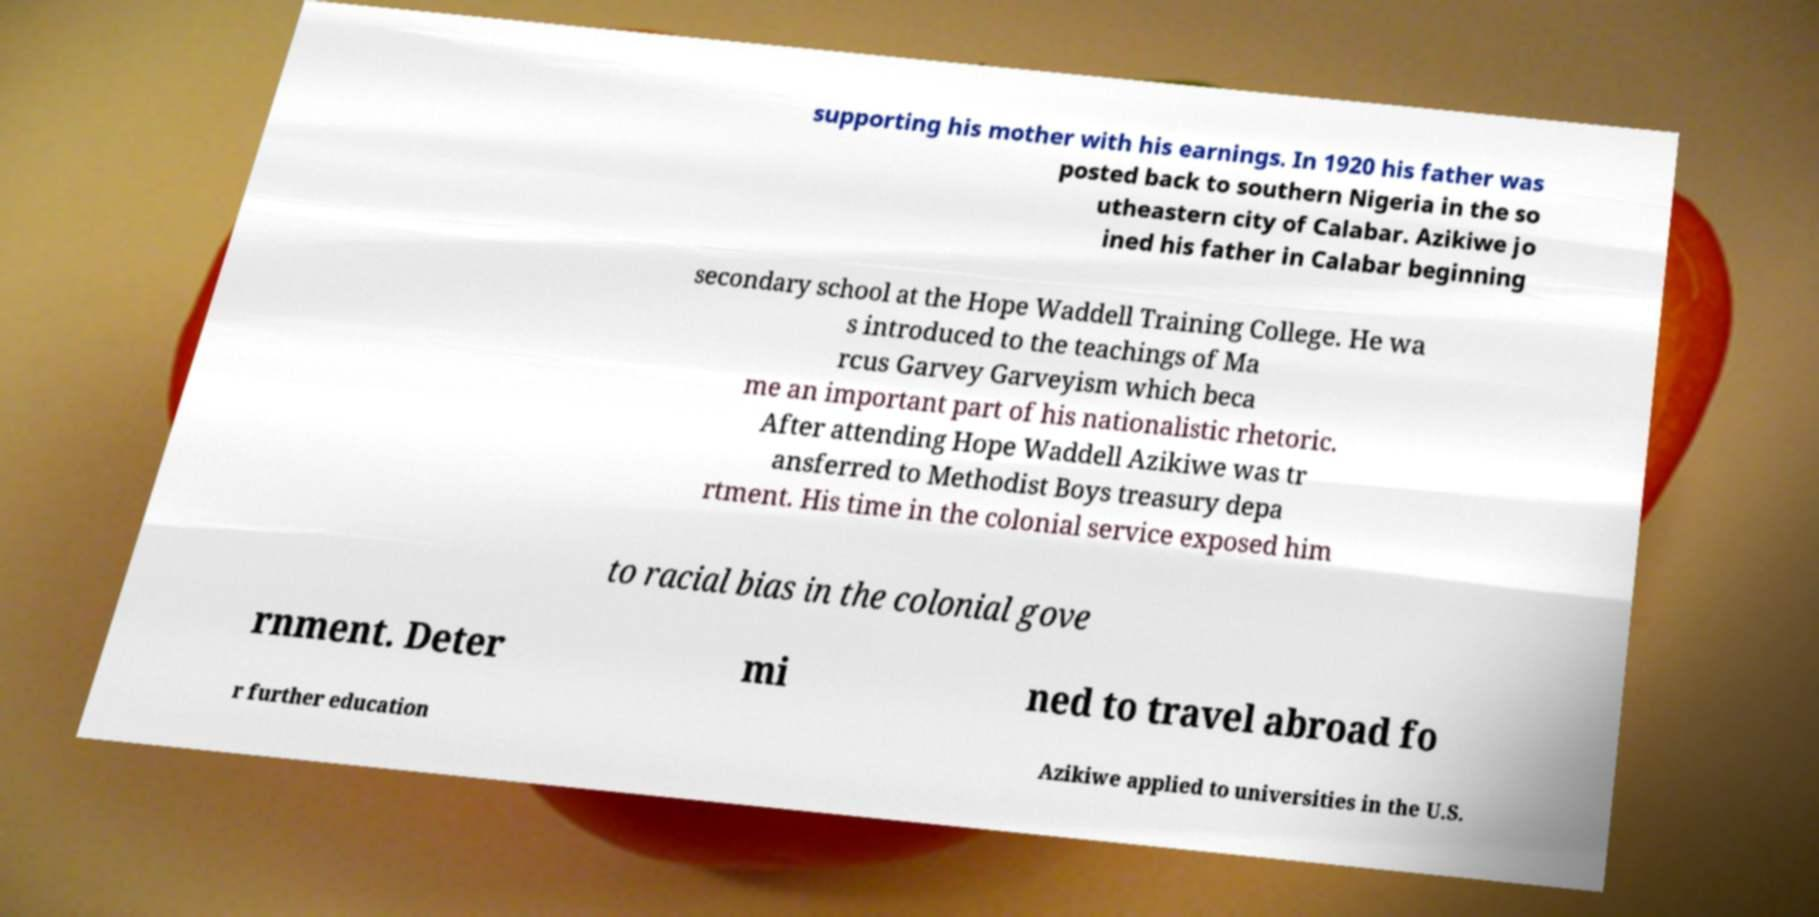Can you read and provide the text displayed in the image?This photo seems to have some interesting text. Can you extract and type it out for me? supporting his mother with his earnings. In 1920 his father was posted back to southern Nigeria in the so utheastern city of Calabar. Azikiwe jo ined his father in Calabar beginning secondary school at the Hope Waddell Training College. He wa s introduced to the teachings of Ma rcus Garvey Garveyism which beca me an important part of his nationalistic rhetoric. After attending Hope Waddell Azikiwe was tr ansferred to Methodist Boys treasury depa rtment. His time in the colonial service exposed him to racial bias in the colonial gove rnment. Deter mi ned to travel abroad fo r further education Azikiwe applied to universities in the U.S. 